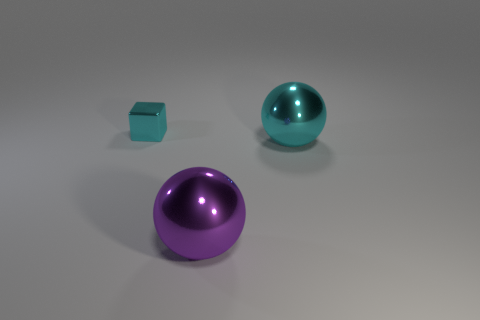Add 2 cyan spheres. How many objects exist? 5 Subtract all spheres. How many objects are left? 1 Subtract all large purple objects. Subtract all big shiny objects. How many objects are left? 0 Add 1 small things. How many small things are left? 2 Add 1 large brown matte balls. How many large brown matte balls exist? 1 Subtract 1 cyan cubes. How many objects are left? 2 